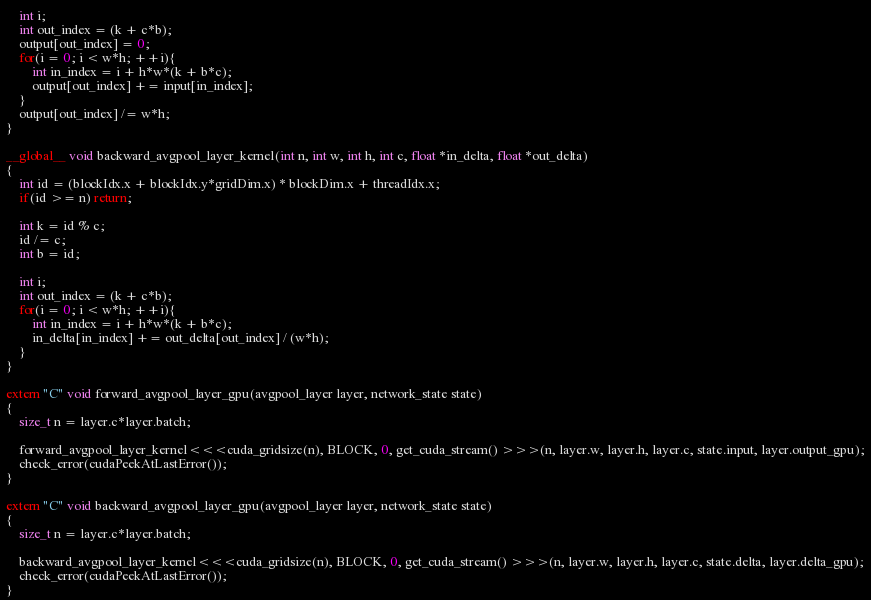<code> <loc_0><loc_0><loc_500><loc_500><_Cuda_>    int i;
    int out_index = (k + c*b);
    output[out_index] = 0;
    for(i = 0; i < w*h; ++i){
        int in_index = i + h*w*(k + b*c);
        output[out_index] += input[in_index];
    }
    output[out_index] /= w*h;
}

__global__ void backward_avgpool_layer_kernel(int n, int w, int h, int c, float *in_delta, float *out_delta)
{
    int id = (blockIdx.x + blockIdx.y*gridDim.x) * blockDim.x + threadIdx.x;
    if(id >= n) return;

    int k = id % c;
    id /= c;
    int b = id;

    int i;
    int out_index = (k + c*b);
    for(i = 0; i < w*h; ++i){
        int in_index = i + h*w*(k + b*c);
        in_delta[in_index] += out_delta[out_index] / (w*h);
    }
}

extern "C" void forward_avgpool_layer_gpu(avgpool_layer layer, network_state state)
{
    size_t n = layer.c*layer.batch;

    forward_avgpool_layer_kernel<<<cuda_gridsize(n), BLOCK, 0, get_cuda_stream() >>>(n, layer.w, layer.h, layer.c, state.input, layer.output_gpu);
    check_error(cudaPeekAtLastError());
}

extern "C" void backward_avgpool_layer_gpu(avgpool_layer layer, network_state state)
{
    size_t n = layer.c*layer.batch;

    backward_avgpool_layer_kernel<<<cuda_gridsize(n), BLOCK, 0, get_cuda_stream() >>>(n, layer.w, layer.h, layer.c, state.delta, layer.delta_gpu);
    check_error(cudaPeekAtLastError());
}

</code> 